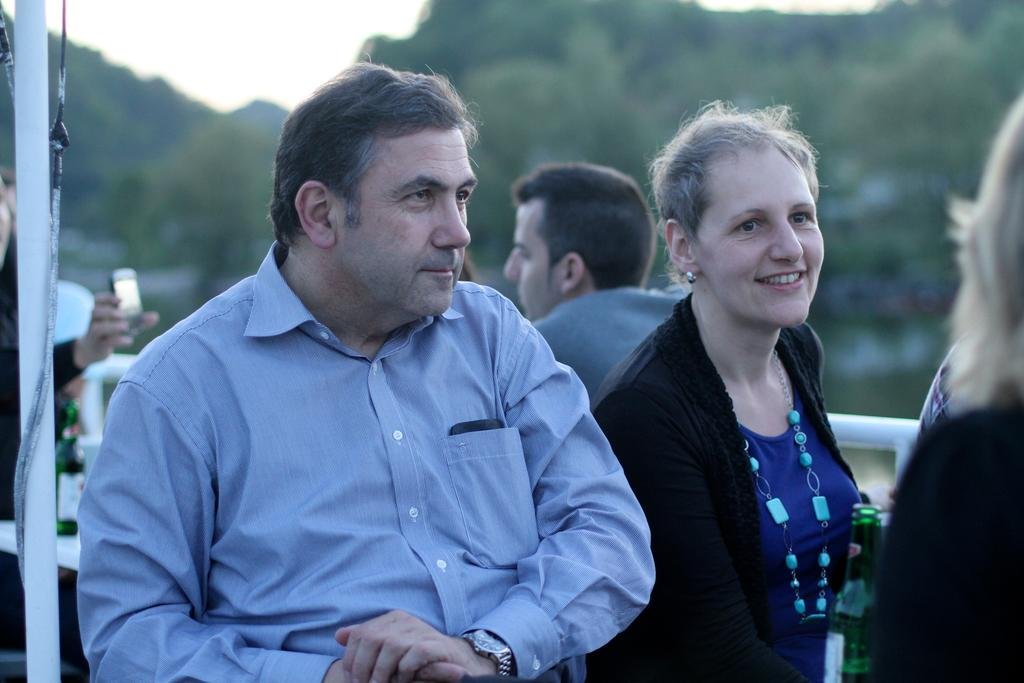What are the people in the image doing? The persons in the image are sitting on chairs. What can be seen in the background of the image? There is sky and trees visible in the background of the image. What items are present on the table in the image? Beverage bottles are present on a table in the image. What object can be seen in the image that is not related to seating or beverages? There is a pole in the image. What type of bait is being used by the persons sitting on chairs in the image? There is no indication of fishing or bait in the image; the persons are simply sitting on chairs. What is the edge of the table made of in the image? The edge of the table is not described in the image, so we cannot determine its material. 